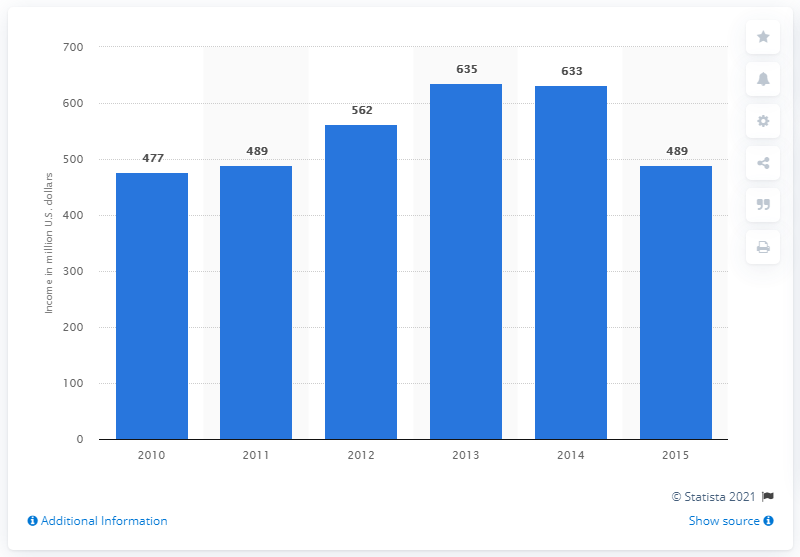Give some essential details in this illustration. Starwood's net income in 2015 was $489 million in dollars. 